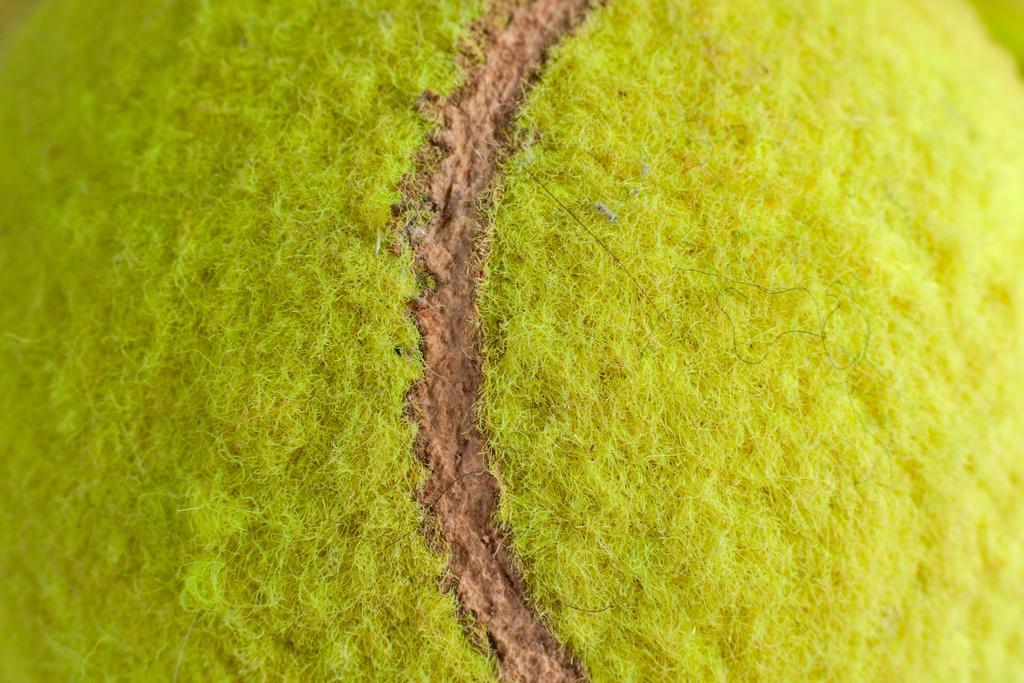Please provide a concise description of this image. In this image there is a tennis ball. 